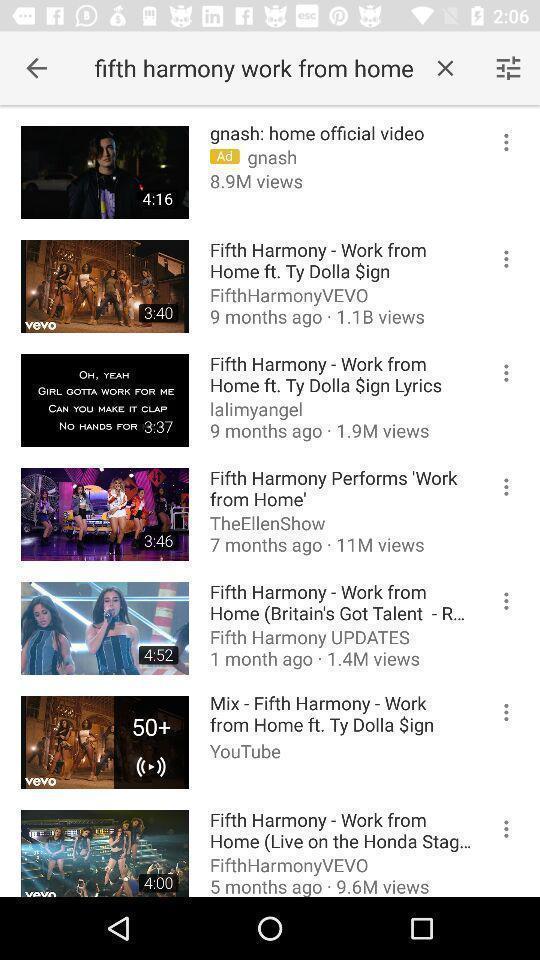Please provide a description for this image. Screen showing list of multiple videos in video player app. 